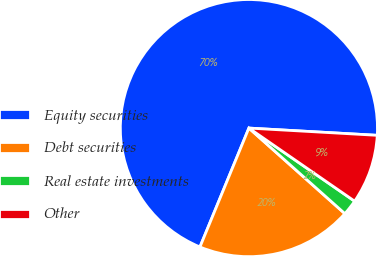Convert chart to OTSL. <chart><loc_0><loc_0><loc_500><loc_500><pie_chart><fcel>Equity securities<fcel>Debt securities<fcel>Real estate investments<fcel>Other<nl><fcel>69.68%<fcel>19.63%<fcel>1.96%<fcel>8.73%<nl></chart> 